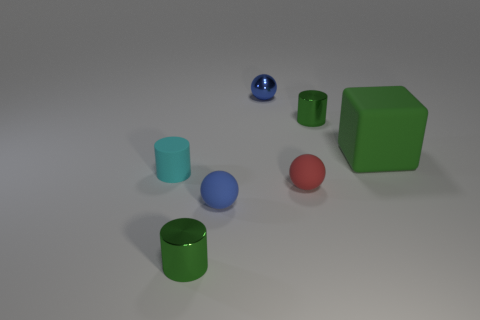Add 2 green cubes. How many objects exist? 9 Subtract all blocks. How many objects are left? 6 Add 4 blue matte balls. How many blue matte balls exist? 5 Subtract 1 green cylinders. How many objects are left? 6 Subtract all green things. Subtract all tiny blue things. How many objects are left? 2 Add 2 small green objects. How many small green objects are left? 4 